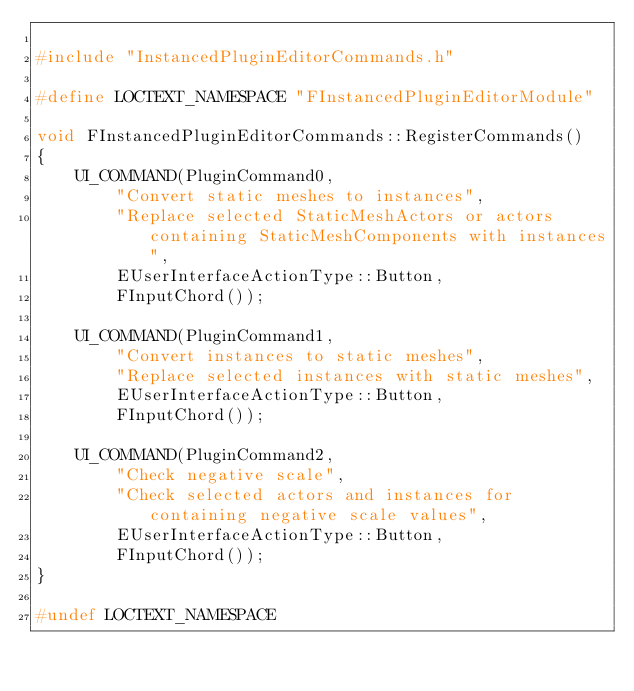<code> <loc_0><loc_0><loc_500><loc_500><_C++_>
#include "InstancedPluginEditorCommands.h"

#define LOCTEXT_NAMESPACE "FInstancedPluginEditorModule"

void FInstancedPluginEditorCommands::RegisterCommands()
{
	UI_COMMAND(PluginCommand0,
		"Convert static meshes to instances",
		"Replace selected StaticMeshActors or actors containing StaticMeshComponents with instances",
		EUserInterfaceActionType::Button,
		FInputChord());

	UI_COMMAND(PluginCommand1,
		"Convert instances to static meshes",
		"Replace selected instances with static meshes",
		EUserInterfaceActionType::Button,
		FInputChord());

	UI_COMMAND(PluginCommand2,
		"Check negative scale",
		"Check selected actors and instances for containing negative scale values",
		EUserInterfaceActionType::Button,
		FInputChord());
}

#undef LOCTEXT_NAMESPACE
</code> 